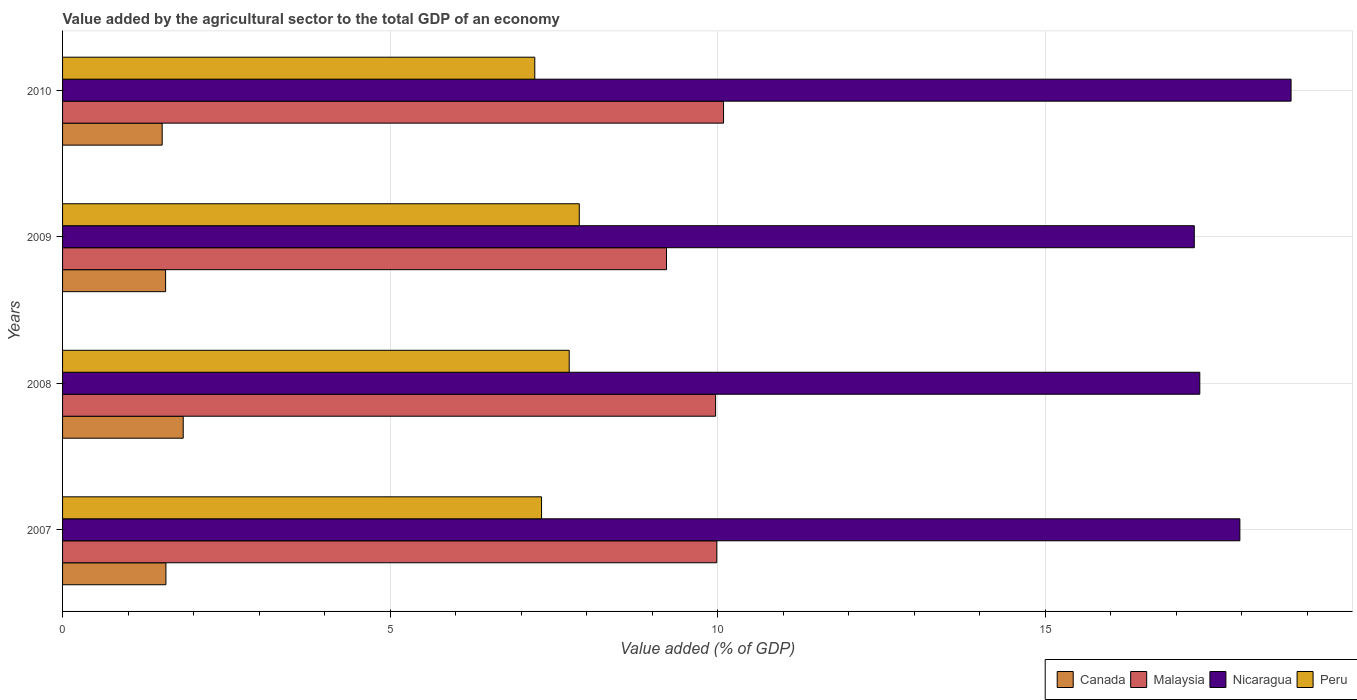How many different coloured bars are there?
Give a very brief answer. 4. Are the number of bars per tick equal to the number of legend labels?
Make the answer very short. Yes. How many bars are there on the 3rd tick from the bottom?
Give a very brief answer. 4. What is the value added by the agricultural sector to the total GDP in Canada in 2008?
Give a very brief answer. 1.84. Across all years, what is the maximum value added by the agricultural sector to the total GDP in Malaysia?
Your answer should be very brief. 10.09. Across all years, what is the minimum value added by the agricultural sector to the total GDP in Nicaragua?
Make the answer very short. 17.28. In which year was the value added by the agricultural sector to the total GDP in Nicaragua maximum?
Keep it short and to the point. 2010. In which year was the value added by the agricultural sector to the total GDP in Malaysia minimum?
Make the answer very short. 2009. What is the total value added by the agricultural sector to the total GDP in Malaysia in the graph?
Your answer should be compact. 39.26. What is the difference between the value added by the agricultural sector to the total GDP in Nicaragua in 2007 and that in 2008?
Provide a succinct answer. 0.61. What is the difference between the value added by the agricultural sector to the total GDP in Malaysia in 2009 and the value added by the agricultural sector to the total GDP in Nicaragua in 2007?
Offer a very short reply. -8.75. What is the average value added by the agricultural sector to the total GDP in Nicaragua per year?
Keep it short and to the point. 17.84. In the year 2008, what is the difference between the value added by the agricultural sector to the total GDP in Malaysia and value added by the agricultural sector to the total GDP in Peru?
Provide a succinct answer. 2.23. In how many years, is the value added by the agricultural sector to the total GDP in Canada greater than 9 %?
Give a very brief answer. 0. What is the ratio of the value added by the agricultural sector to the total GDP in Peru in 2007 to that in 2009?
Your answer should be very brief. 0.93. Is the value added by the agricultural sector to the total GDP in Nicaragua in 2008 less than that in 2009?
Give a very brief answer. No. Is the difference between the value added by the agricultural sector to the total GDP in Malaysia in 2009 and 2010 greater than the difference between the value added by the agricultural sector to the total GDP in Peru in 2009 and 2010?
Keep it short and to the point. No. What is the difference between the highest and the second highest value added by the agricultural sector to the total GDP in Malaysia?
Ensure brevity in your answer.  0.1. What is the difference between the highest and the lowest value added by the agricultural sector to the total GDP in Canada?
Your answer should be compact. 0.32. In how many years, is the value added by the agricultural sector to the total GDP in Peru greater than the average value added by the agricultural sector to the total GDP in Peru taken over all years?
Make the answer very short. 2. Is the sum of the value added by the agricultural sector to the total GDP in Malaysia in 2008 and 2010 greater than the maximum value added by the agricultural sector to the total GDP in Peru across all years?
Your answer should be compact. Yes. Is it the case that in every year, the sum of the value added by the agricultural sector to the total GDP in Peru and value added by the agricultural sector to the total GDP in Canada is greater than the sum of value added by the agricultural sector to the total GDP in Malaysia and value added by the agricultural sector to the total GDP in Nicaragua?
Offer a very short reply. No. What does the 3rd bar from the top in 2008 represents?
Make the answer very short. Malaysia. What does the 2nd bar from the bottom in 2009 represents?
Offer a terse response. Malaysia. How many bars are there?
Provide a short and direct response. 16. Are all the bars in the graph horizontal?
Make the answer very short. Yes. Are the values on the major ticks of X-axis written in scientific E-notation?
Keep it short and to the point. No. Where does the legend appear in the graph?
Offer a terse response. Bottom right. How many legend labels are there?
Offer a very short reply. 4. How are the legend labels stacked?
Your answer should be compact. Horizontal. What is the title of the graph?
Offer a very short reply. Value added by the agricultural sector to the total GDP of an economy. Does "Uzbekistan" appear as one of the legend labels in the graph?
Offer a terse response. No. What is the label or title of the X-axis?
Ensure brevity in your answer.  Value added (% of GDP). What is the label or title of the Y-axis?
Provide a short and direct response. Years. What is the Value added (% of GDP) in Canada in 2007?
Keep it short and to the point. 1.58. What is the Value added (% of GDP) in Malaysia in 2007?
Your answer should be compact. 9.99. What is the Value added (% of GDP) in Nicaragua in 2007?
Your response must be concise. 17.97. What is the Value added (% of GDP) of Peru in 2007?
Offer a very short reply. 7.31. What is the Value added (% of GDP) in Canada in 2008?
Give a very brief answer. 1.84. What is the Value added (% of GDP) in Malaysia in 2008?
Keep it short and to the point. 9.97. What is the Value added (% of GDP) in Nicaragua in 2008?
Your response must be concise. 17.36. What is the Value added (% of GDP) in Peru in 2008?
Your answer should be very brief. 7.73. What is the Value added (% of GDP) in Canada in 2009?
Make the answer very short. 1.57. What is the Value added (% of GDP) of Malaysia in 2009?
Ensure brevity in your answer.  9.22. What is the Value added (% of GDP) in Nicaragua in 2009?
Offer a very short reply. 17.28. What is the Value added (% of GDP) of Peru in 2009?
Your answer should be very brief. 7.89. What is the Value added (% of GDP) of Canada in 2010?
Ensure brevity in your answer.  1.52. What is the Value added (% of GDP) of Malaysia in 2010?
Your answer should be very brief. 10.09. What is the Value added (% of GDP) in Nicaragua in 2010?
Your answer should be compact. 18.75. What is the Value added (% of GDP) of Peru in 2010?
Make the answer very short. 7.21. Across all years, what is the maximum Value added (% of GDP) in Canada?
Your answer should be compact. 1.84. Across all years, what is the maximum Value added (% of GDP) in Malaysia?
Make the answer very short. 10.09. Across all years, what is the maximum Value added (% of GDP) of Nicaragua?
Offer a terse response. 18.75. Across all years, what is the maximum Value added (% of GDP) of Peru?
Your response must be concise. 7.89. Across all years, what is the minimum Value added (% of GDP) in Canada?
Your answer should be compact. 1.52. Across all years, what is the minimum Value added (% of GDP) of Malaysia?
Provide a short and direct response. 9.22. Across all years, what is the minimum Value added (% of GDP) of Nicaragua?
Provide a succinct answer. 17.28. Across all years, what is the minimum Value added (% of GDP) in Peru?
Your answer should be compact. 7.21. What is the total Value added (% of GDP) of Canada in the graph?
Offer a very short reply. 6.51. What is the total Value added (% of GDP) in Malaysia in the graph?
Give a very brief answer. 39.26. What is the total Value added (% of GDP) of Nicaragua in the graph?
Provide a short and direct response. 71.36. What is the total Value added (% of GDP) of Peru in the graph?
Provide a short and direct response. 30.14. What is the difference between the Value added (% of GDP) in Canada in 2007 and that in 2008?
Offer a terse response. -0.26. What is the difference between the Value added (% of GDP) of Malaysia in 2007 and that in 2008?
Offer a terse response. 0.02. What is the difference between the Value added (% of GDP) of Nicaragua in 2007 and that in 2008?
Offer a very short reply. 0.61. What is the difference between the Value added (% of GDP) in Peru in 2007 and that in 2008?
Your answer should be compact. -0.42. What is the difference between the Value added (% of GDP) of Canada in 2007 and that in 2009?
Provide a succinct answer. 0.01. What is the difference between the Value added (% of GDP) in Malaysia in 2007 and that in 2009?
Make the answer very short. 0.77. What is the difference between the Value added (% of GDP) of Nicaragua in 2007 and that in 2009?
Make the answer very short. 0.7. What is the difference between the Value added (% of GDP) in Peru in 2007 and that in 2009?
Make the answer very short. -0.58. What is the difference between the Value added (% of GDP) in Canada in 2007 and that in 2010?
Offer a very short reply. 0.06. What is the difference between the Value added (% of GDP) of Malaysia in 2007 and that in 2010?
Your response must be concise. -0.1. What is the difference between the Value added (% of GDP) of Nicaragua in 2007 and that in 2010?
Offer a terse response. -0.78. What is the difference between the Value added (% of GDP) in Peru in 2007 and that in 2010?
Your response must be concise. 0.1. What is the difference between the Value added (% of GDP) of Canada in 2008 and that in 2009?
Give a very brief answer. 0.27. What is the difference between the Value added (% of GDP) of Malaysia in 2008 and that in 2009?
Make the answer very short. 0.75. What is the difference between the Value added (% of GDP) in Nicaragua in 2008 and that in 2009?
Offer a very short reply. 0.08. What is the difference between the Value added (% of GDP) of Peru in 2008 and that in 2009?
Your answer should be very brief. -0.15. What is the difference between the Value added (% of GDP) in Canada in 2008 and that in 2010?
Your answer should be compact. 0.32. What is the difference between the Value added (% of GDP) in Malaysia in 2008 and that in 2010?
Provide a succinct answer. -0.12. What is the difference between the Value added (% of GDP) in Nicaragua in 2008 and that in 2010?
Provide a short and direct response. -1.39. What is the difference between the Value added (% of GDP) in Peru in 2008 and that in 2010?
Provide a short and direct response. 0.53. What is the difference between the Value added (% of GDP) in Canada in 2009 and that in 2010?
Offer a very short reply. 0.05. What is the difference between the Value added (% of GDP) of Malaysia in 2009 and that in 2010?
Make the answer very short. -0.87. What is the difference between the Value added (% of GDP) in Nicaragua in 2009 and that in 2010?
Give a very brief answer. -1.48. What is the difference between the Value added (% of GDP) in Peru in 2009 and that in 2010?
Offer a terse response. 0.68. What is the difference between the Value added (% of GDP) of Canada in 2007 and the Value added (% of GDP) of Malaysia in 2008?
Your response must be concise. -8.39. What is the difference between the Value added (% of GDP) in Canada in 2007 and the Value added (% of GDP) in Nicaragua in 2008?
Offer a very short reply. -15.78. What is the difference between the Value added (% of GDP) of Canada in 2007 and the Value added (% of GDP) of Peru in 2008?
Ensure brevity in your answer.  -6.16. What is the difference between the Value added (% of GDP) in Malaysia in 2007 and the Value added (% of GDP) in Nicaragua in 2008?
Give a very brief answer. -7.37. What is the difference between the Value added (% of GDP) of Malaysia in 2007 and the Value added (% of GDP) of Peru in 2008?
Keep it short and to the point. 2.25. What is the difference between the Value added (% of GDP) in Nicaragua in 2007 and the Value added (% of GDP) in Peru in 2008?
Offer a very short reply. 10.24. What is the difference between the Value added (% of GDP) in Canada in 2007 and the Value added (% of GDP) in Malaysia in 2009?
Offer a very short reply. -7.64. What is the difference between the Value added (% of GDP) in Canada in 2007 and the Value added (% of GDP) in Nicaragua in 2009?
Your answer should be compact. -15.7. What is the difference between the Value added (% of GDP) of Canada in 2007 and the Value added (% of GDP) of Peru in 2009?
Your response must be concise. -6.31. What is the difference between the Value added (% of GDP) in Malaysia in 2007 and the Value added (% of GDP) in Nicaragua in 2009?
Your answer should be compact. -7.29. What is the difference between the Value added (% of GDP) of Malaysia in 2007 and the Value added (% of GDP) of Peru in 2009?
Provide a short and direct response. 2.1. What is the difference between the Value added (% of GDP) in Nicaragua in 2007 and the Value added (% of GDP) in Peru in 2009?
Give a very brief answer. 10.08. What is the difference between the Value added (% of GDP) of Canada in 2007 and the Value added (% of GDP) of Malaysia in 2010?
Offer a terse response. -8.51. What is the difference between the Value added (% of GDP) of Canada in 2007 and the Value added (% of GDP) of Nicaragua in 2010?
Make the answer very short. -17.18. What is the difference between the Value added (% of GDP) of Canada in 2007 and the Value added (% of GDP) of Peru in 2010?
Ensure brevity in your answer.  -5.63. What is the difference between the Value added (% of GDP) of Malaysia in 2007 and the Value added (% of GDP) of Nicaragua in 2010?
Provide a succinct answer. -8.77. What is the difference between the Value added (% of GDP) of Malaysia in 2007 and the Value added (% of GDP) of Peru in 2010?
Provide a succinct answer. 2.78. What is the difference between the Value added (% of GDP) of Nicaragua in 2007 and the Value added (% of GDP) of Peru in 2010?
Give a very brief answer. 10.76. What is the difference between the Value added (% of GDP) of Canada in 2008 and the Value added (% of GDP) of Malaysia in 2009?
Provide a succinct answer. -7.38. What is the difference between the Value added (% of GDP) of Canada in 2008 and the Value added (% of GDP) of Nicaragua in 2009?
Offer a very short reply. -15.43. What is the difference between the Value added (% of GDP) of Canada in 2008 and the Value added (% of GDP) of Peru in 2009?
Provide a succinct answer. -6.05. What is the difference between the Value added (% of GDP) in Malaysia in 2008 and the Value added (% of GDP) in Nicaragua in 2009?
Keep it short and to the point. -7.31. What is the difference between the Value added (% of GDP) of Malaysia in 2008 and the Value added (% of GDP) of Peru in 2009?
Your answer should be very brief. 2.08. What is the difference between the Value added (% of GDP) in Nicaragua in 2008 and the Value added (% of GDP) in Peru in 2009?
Your answer should be very brief. 9.47. What is the difference between the Value added (% of GDP) in Canada in 2008 and the Value added (% of GDP) in Malaysia in 2010?
Offer a very short reply. -8.25. What is the difference between the Value added (% of GDP) of Canada in 2008 and the Value added (% of GDP) of Nicaragua in 2010?
Your response must be concise. -16.91. What is the difference between the Value added (% of GDP) in Canada in 2008 and the Value added (% of GDP) in Peru in 2010?
Ensure brevity in your answer.  -5.37. What is the difference between the Value added (% of GDP) in Malaysia in 2008 and the Value added (% of GDP) in Nicaragua in 2010?
Your answer should be compact. -8.78. What is the difference between the Value added (% of GDP) in Malaysia in 2008 and the Value added (% of GDP) in Peru in 2010?
Provide a short and direct response. 2.76. What is the difference between the Value added (% of GDP) of Nicaragua in 2008 and the Value added (% of GDP) of Peru in 2010?
Give a very brief answer. 10.15. What is the difference between the Value added (% of GDP) in Canada in 2009 and the Value added (% of GDP) in Malaysia in 2010?
Provide a short and direct response. -8.52. What is the difference between the Value added (% of GDP) in Canada in 2009 and the Value added (% of GDP) in Nicaragua in 2010?
Your answer should be compact. -17.18. What is the difference between the Value added (% of GDP) in Canada in 2009 and the Value added (% of GDP) in Peru in 2010?
Ensure brevity in your answer.  -5.64. What is the difference between the Value added (% of GDP) in Malaysia in 2009 and the Value added (% of GDP) in Nicaragua in 2010?
Offer a very short reply. -9.53. What is the difference between the Value added (% of GDP) in Malaysia in 2009 and the Value added (% of GDP) in Peru in 2010?
Your answer should be very brief. 2.01. What is the difference between the Value added (% of GDP) in Nicaragua in 2009 and the Value added (% of GDP) in Peru in 2010?
Make the answer very short. 10.07. What is the average Value added (% of GDP) in Canada per year?
Offer a very short reply. 1.63. What is the average Value added (% of GDP) of Malaysia per year?
Provide a short and direct response. 9.82. What is the average Value added (% of GDP) of Nicaragua per year?
Your response must be concise. 17.84. What is the average Value added (% of GDP) in Peru per year?
Offer a terse response. 7.54. In the year 2007, what is the difference between the Value added (% of GDP) in Canada and Value added (% of GDP) in Malaysia?
Make the answer very short. -8.41. In the year 2007, what is the difference between the Value added (% of GDP) in Canada and Value added (% of GDP) in Nicaragua?
Give a very brief answer. -16.39. In the year 2007, what is the difference between the Value added (% of GDP) in Canada and Value added (% of GDP) in Peru?
Ensure brevity in your answer.  -5.73. In the year 2007, what is the difference between the Value added (% of GDP) in Malaysia and Value added (% of GDP) in Nicaragua?
Offer a very short reply. -7.98. In the year 2007, what is the difference between the Value added (% of GDP) of Malaysia and Value added (% of GDP) of Peru?
Provide a short and direct response. 2.68. In the year 2007, what is the difference between the Value added (% of GDP) of Nicaragua and Value added (% of GDP) of Peru?
Give a very brief answer. 10.66. In the year 2008, what is the difference between the Value added (% of GDP) in Canada and Value added (% of GDP) in Malaysia?
Keep it short and to the point. -8.13. In the year 2008, what is the difference between the Value added (% of GDP) in Canada and Value added (% of GDP) in Nicaragua?
Offer a very short reply. -15.52. In the year 2008, what is the difference between the Value added (% of GDP) in Canada and Value added (% of GDP) in Peru?
Ensure brevity in your answer.  -5.89. In the year 2008, what is the difference between the Value added (% of GDP) in Malaysia and Value added (% of GDP) in Nicaragua?
Your response must be concise. -7.39. In the year 2008, what is the difference between the Value added (% of GDP) in Malaysia and Value added (% of GDP) in Peru?
Your answer should be very brief. 2.23. In the year 2008, what is the difference between the Value added (% of GDP) in Nicaragua and Value added (% of GDP) in Peru?
Your response must be concise. 9.63. In the year 2009, what is the difference between the Value added (% of GDP) in Canada and Value added (% of GDP) in Malaysia?
Your response must be concise. -7.65. In the year 2009, what is the difference between the Value added (% of GDP) in Canada and Value added (% of GDP) in Nicaragua?
Provide a succinct answer. -15.7. In the year 2009, what is the difference between the Value added (% of GDP) in Canada and Value added (% of GDP) in Peru?
Offer a terse response. -6.32. In the year 2009, what is the difference between the Value added (% of GDP) of Malaysia and Value added (% of GDP) of Nicaragua?
Provide a succinct answer. -8.06. In the year 2009, what is the difference between the Value added (% of GDP) in Malaysia and Value added (% of GDP) in Peru?
Your answer should be very brief. 1.33. In the year 2009, what is the difference between the Value added (% of GDP) of Nicaragua and Value added (% of GDP) of Peru?
Offer a terse response. 9.39. In the year 2010, what is the difference between the Value added (% of GDP) of Canada and Value added (% of GDP) of Malaysia?
Your response must be concise. -8.57. In the year 2010, what is the difference between the Value added (% of GDP) of Canada and Value added (% of GDP) of Nicaragua?
Keep it short and to the point. -17.23. In the year 2010, what is the difference between the Value added (% of GDP) of Canada and Value added (% of GDP) of Peru?
Give a very brief answer. -5.69. In the year 2010, what is the difference between the Value added (% of GDP) in Malaysia and Value added (% of GDP) in Nicaragua?
Ensure brevity in your answer.  -8.66. In the year 2010, what is the difference between the Value added (% of GDP) of Malaysia and Value added (% of GDP) of Peru?
Your answer should be compact. 2.88. In the year 2010, what is the difference between the Value added (% of GDP) of Nicaragua and Value added (% of GDP) of Peru?
Your answer should be very brief. 11.54. What is the ratio of the Value added (% of GDP) in Canada in 2007 to that in 2008?
Make the answer very short. 0.86. What is the ratio of the Value added (% of GDP) in Nicaragua in 2007 to that in 2008?
Provide a succinct answer. 1.04. What is the ratio of the Value added (% of GDP) in Peru in 2007 to that in 2008?
Provide a short and direct response. 0.95. What is the ratio of the Value added (% of GDP) of Canada in 2007 to that in 2009?
Offer a very short reply. 1. What is the ratio of the Value added (% of GDP) of Nicaragua in 2007 to that in 2009?
Make the answer very short. 1.04. What is the ratio of the Value added (% of GDP) of Peru in 2007 to that in 2009?
Your answer should be compact. 0.93. What is the ratio of the Value added (% of GDP) of Canada in 2007 to that in 2010?
Keep it short and to the point. 1.04. What is the ratio of the Value added (% of GDP) of Nicaragua in 2007 to that in 2010?
Provide a short and direct response. 0.96. What is the ratio of the Value added (% of GDP) in Peru in 2007 to that in 2010?
Offer a very short reply. 1.01. What is the ratio of the Value added (% of GDP) in Canada in 2008 to that in 2009?
Ensure brevity in your answer.  1.17. What is the ratio of the Value added (% of GDP) in Malaysia in 2008 to that in 2009?
Offer a very short reply. 1.08. What is the ratio of the Value added (% of GDP) in Nicaragua in 2008 to that in 2009?
Provide a succinct answer. 1. What is the ratio of the Value added (% of GDP) in Peru in 2008 to that in 2009?
Make the answer very short. 0.98. What is the ratio of the Value added (% of GDP) of Canada in 2008 to that in 2010?
Your answer should be compact. 1.21. What is the ratio of the Value added (% of GDP) of Malaysia in 2008 to that in 2010?
Your answer should be compact. 0.99. What is the ratio of the Value added (% of GDP) of Nicaragua in 2008 to that in 2010?
Your answer should be compact. 0.93. What is the ratio of the Value added (% of GDP) of Peru in 2008 to that in 2010?
Ensure brevity in your answer.  1.07. What is the ratio of the Value added (% of GDP) of Canada in 2009 to that in 2010?
Provide a succinct answer. 1.03. What is the ratio of the Value added (% of GDP) of Malaysia in 2009 to that in 2010?
Keep it short and to the point. 0.91. What is the ratio of the Value added (% of GDP) of Nicaragua in 2009 to that in 2010?
Offer a very short reply. 0.92. What is the ratio of the Value added (% of GDP) of Peru in 2009 to that in 2010?
Offer a very short reply. 1.09. What is the difference between the highest and the second highest Value added (% of GDP) of Canada?
Keep it short and to the point. 0.26. What is the difference between the highest and the second highest Value added (% of GDP) in Malaysia?
Offer a very short reply. 0.1. What is the difference between the highest and the second highest Value added (% of GDP) of Nicaragua?
Your response must be concise. 0.78. What is the difference between the highest and the second highest Value added (% of GDP) in Peru?
Your response must be concise. 0.15. What is the difference between the highest and the lowest Value added (% of GDP) in Canada?
Keep it short and to the point. 0.32. What is the difference between the highest and the lowest Value added (% of GDP) of Malaysia?
Your answer should be compact. 0.87. What is the difference between the highest and the lowest Value added (% of GDP) in Nicaragua?
Keep it short and to the point. 1.48. What is the difference between the highest and the lowest Value added (% of GDP) of Peru?
Your answer should be very brief. 0.68. 